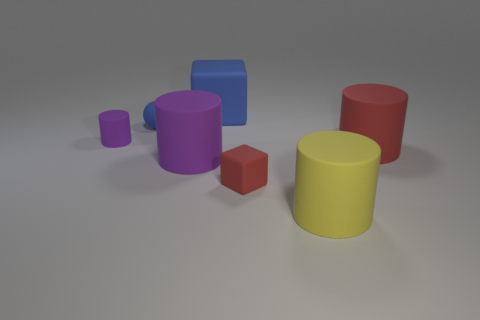Subtract all big purple matte cylinders. How many cylinders are left? 3 Subtract all yellow cylinders. How many cylinders are left? 3 Add 2 tiny blue metallic blocks. How many objects exist? 9 Subtract all spheres. How many objects are left? 6 Subtract 2 blocks. How many blocks are left? 0 Subtract all blue spheres. How many blue blocks are left? 1 Subtract all big cyan cylinders. Subtract all big yellow rubber objects. How many objects are left? 6 Add 3 blue balls. How many blue balls are left? 4 Add 6 red cylinders. How many red cylinders exist? 7 Subtract 0 brown cylinders. How many objects are left? 7 